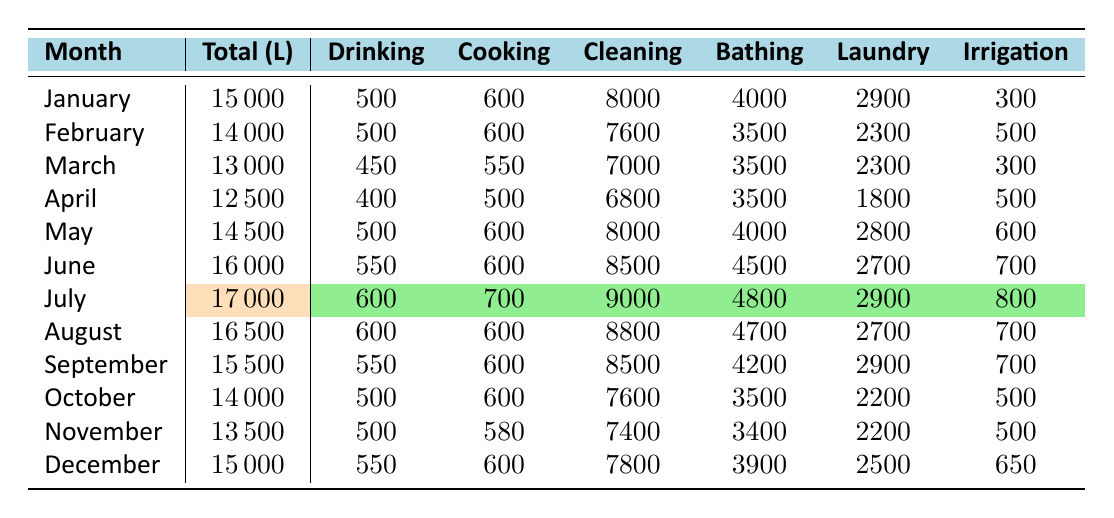What is the total water usage in July? The table shows that the total water usage for July is specifically mentioned as 17000 liters.
Answer: 17000 liters Which month had the highest water usage? By reviewing the "Total (L)" column, July has the highest value at 17000 liters, greater than any other month's usage.
Answer: July What is the total water usage for the first half of the year (January to June)? Summing the total usage for each month gives: 15000 + 14000 + 13000 + 12500 + 14500 + 16000 = 95000 liters for the first half.
Answer: 95000 liters How much water is used for cleaning in August? The table indicates that cleaning usage in August is 8800 liters, which is noted under the "Cleaning" column for that month.
Answer: 8800 liters Is the drinking water usage higher in December than in November? In December, drinking water usage is 550 liters, while in November it is 500 liters. Therefore, December has higher usage.
Answer: Yes What is the average monthly water usage for the year? To find the average, sum all monthly usages (15000 + 14000 + 13000 + 12500 + 14500 + 16000 + 17000 + 16500 + 15500 + 14000 + 13500 + 15000 = 174000 liters) and divide by 12 months: 174000 / 12 = 14500 liters.
Answer: 14500 liters Which month had the least usage of water for drinking? By looking at the "Drinking" column, March has the least drinking water usage at 450 liters compared to other months.
Answer: March How much more water was used for cleaning in June compared to April? In June, the cleaning usage was 8500 liters and in April, it was 6800 liters. The difference is 8500 - 6800 = 1700 liters more used in June.
Answer: 1700 liters What is the total irrigation water usage for the whole year? Adding the irrigation amounts for each month gives: 300 + 500 + 300 + 500 + 600 + 700 + 800 + 700 + 700 + 500 + 500 + 650 = 7500 liters.
Answer: 7500 liters In which month did the household use the most water for laundry? The laundry usage peaked at 2900 liters in both July and September according to the "Laundry" column, which is the highest recorded.
Answer: July and September How does the total water usage in December compare to June? December's total water usage is 15000 liters, while June's is 16000 liters. June had 1000 liters more than December, as we subtract 15000 from 16000.
Answer: June had 1000 liters more 